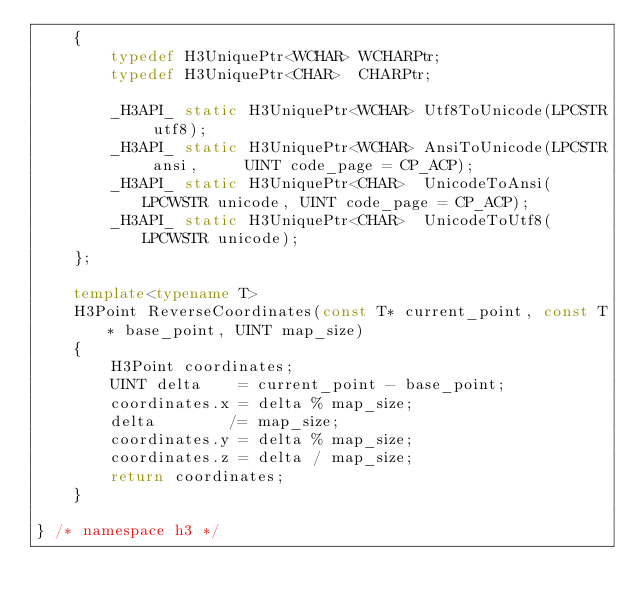Convert code to text. <code><loc_0><loc_0><loc_500><loc_500><_C++_>	{
		typedef H3UniquePtr<WCHAR> WCHARPtr;
		typedef H3UniquePtr<CHAR>  CHARPtr;

		_H3API_ static H3UniquePtr<WCHAR> Utf8ToUnicode(LPCSTR utf8);
		_H3API_ static H3UniquePtr<WCHAR> AnsiToUnicode(LPCSTR ansi,     UINT code_page = CP_ACP);
		_H3API_ static H3UniquePtr<CHAR>  UnicodeToAnsi(LPCWSTR unicode, UINT code_page = CP_ACP);
		_H3API_ static H3UniquePtr<CHAR>  UnicodeToUtf8(LPCWSTR unicode);
	};

	template<typename T>
	H3Point ReverseCoordinates(const T* current_point, const T* base_point, UINT map_size)
	{
		H3Point coordinates;
		UINT delta    = current_point - base_point;
		coordinates.x = delta % map_size;
		delta        /= map_size;
		coordinates.y = delta % map_size;
		coordinates.z = delta / map_size;
		return coordinates;
	}

} /* namespace h3 */
</code> 